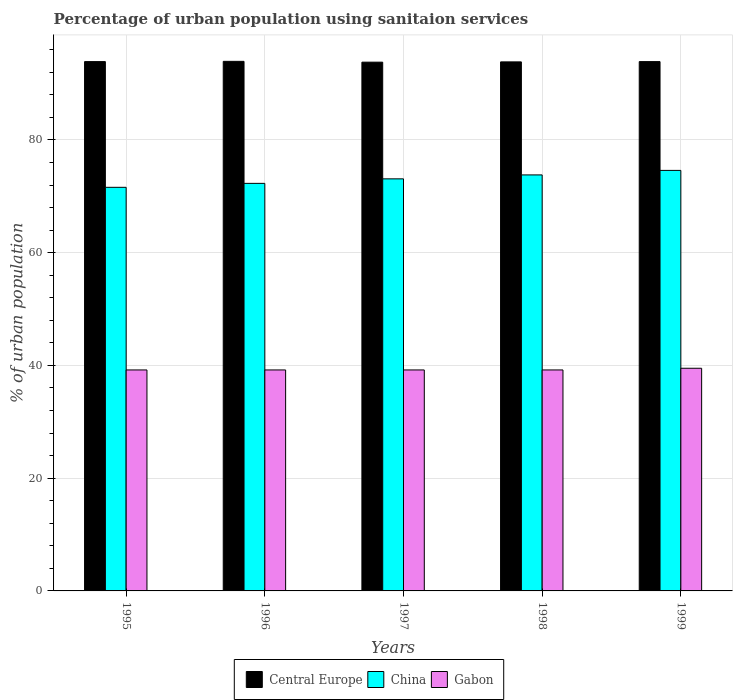How many different coloured bars are there?
Your answer should be very brief. 3. How many bars are there on the 1st tick from the left?
Your response must be concise. 3. In how many cases, is the number of bars for a given year not equal to the number of legend labels?
Ensure brevity in your answer.  0. What is the percentage of urban population using sanitaion services in Gabon in 1995?
Your response must be concise. 39.2. Across all years, what is the maximum percentage of urban population using sanitaion services in Central Europe?
Give a very brief answer. 93.95. Across all years, what is the minimum percentage of urban population using sanitaion services in Gabon?
Give a very brief answer. 39.2. In which year was the percentage of urban population using sanitaion services in China maximum?
Provide a short and direct response. 1999. What is the total percentage of urban population using sanitaion services in China in the graph?
Your response must be concise. 365.4. What is the difference between the percentage of urban population using sanitaion services in Gabon in 1995 and that in 1997?
Offer a terse response. 0. What is the difference between the percentage of urban population using sanitaion services in China in 1998 and the percentage of urban population using sanitaion services in Gabon in 1999?
Provide a short and direct response. 34.3. What is the average percentage of urban population using sanitaion services in Central Europe per year?
Provide a short and direct response. 93.88. In the year 1999, what is the difference between the percentage of urban population using sanitaion services in Gabon and percentage of urban population using sanitaion services in China?
Offer a very short reply. -35.1. What is the ratio of the percentage of urban population using sanitaion services in Gabon in 1998 to that in 1999?
Your answer should be very brief. 0.99. Is the percentage of urban population using sanitaion services in Central Europe in 1997 less than that in 1998?
Keep it short and to the point. Yes. What is the difference between the highest and the second highest percentage of urban population using sanitaion services in Central Europe?
Give a very brief answer. 0.04. What is the difference between the highest and the lowest percentage of urban population using sanitaion services in Central Europe?
Your response must be concise. 0.14. Is the sum of the percentage of urban population using sanitaion services in Central Europe in 1998 and 1999 greater than the maximum percentage of urban population using sanitaion services in Gabon across all years?
Keep it short and to the point. Yes. What does the 1st bar from the left in 1995 represents?
Your response must be concise. Central Europe. What does the 3rd bar from the right in 1995 represents?
Give a very brief answer. Central Europe. Is it the case that in every year, the sum of the percentage of urban population using sanitaion services in Gabon and percentage of urban population using sanitaion services in Central Europe is greater than the percentage of urban population using sanitaion services in China?
Offer a very short reply. Yes. Are the values on the major ticks of Y-axis written in scientific E-notation?
Give a very brief answer. No. Does the graph contain any zero values?
Keep it short and to the point. No. Does the graph contain grids?
Give a very brief answer. Yes. What is the title of the graph?
Give a very brief answer. Percentage of urban population using sanitaion services. Does "Costa Rica" appear as one of the legend labels in the graph?
Your answer should be compact. No. What is the label or title of the Y-axis?
Give a very brief answer. % of urban population. What is the % of urban population in Central Europe in 1995?
Keep it short and to the point. 93.9. What is the % of urban population of China in 1995?
Make the answer very short. 71.6. What is the % of urban population in Gabon in 1995?
Your answer should be compact. 39.2. What is the % of urban population of Central Europe in 1996?
Keep it short and to the point. 93.95. What is the % of urban population in China in 1996?
Give a very brief answer. 72.3. What is the % of urban population of Gabon in 1996?
Offer a terse response. 39.2. What is the % of urban population in Central Europe in 1997?
Give a very brief answer. 93.8. What is the % of urban population of China in 1997?
Make the answer very short. 73.1. What is the % of urban population in Gabon in 1997?
Provide a succinct answer. 39.2. What is the % of urban population of Central Europe in 1998?
Offer a terse response. 93.85. What is the % of urban population in China in 1998?
Offer a terse response. 73.8. What is the % of urban population of Gabon in 1998?
Make the answer very short. 39.2. What is the % of urban population of Central Europe in 1999?
Offer a very short reply. 93.9. What is the % of urban population in China in 1999?
Keep it short and to the point. 74.6. What is the % of urban population of Gabon in 1999?
Ensure brevity in your answer.  39.5. Across all years, what is the maximum % of urban population in Central Europe?
Provide a succinct answer. 93.95. Across all years, what is the maximum % of urban population of China?
Provide a succinct answer. 74.6. Across all years, what is the maximum % of urban population in Gabon?
Give a very brief answer. 39.5. Across all years, what is the minimum % of urban population of Central Europe?
Your answer should be compact. 93.8. Across all years, what is the minimum % of urban population in China?
Give a very brief answer. 71.6. Across all years, what is the minimum % of urban population in Gabon?
Ensure brevity in your answer.  39.2. What is the total % of urban population in Central Europe in the graph?
Your response must be concise. 469.4. What is the total % of urban population in China in the graph?
Provide a short and direct response. 365.4. What is the total % of urban population in Gabon in the graph?
Your response must be concise. 196.3. What is the difference between the % of urban population in Central Europe in 1995 and that in 1996?
Your answer should be very brief. -0.04. What is the difference between the % of urban population in Gabon in 1995 and that in 1996?
Keep it short and to the point. 0. What is the difference between the % of urban population of Central Europe in 1995 and that in 1997?
Keep it short and to the point. 0.1. What is the difference between the % of urban population in China in 1995 and that in 1997?
Your answer should be compact. -1.5. What is the difference between the % of urban population of Gabon in 1995 and that in 1997?
Your answer should be very brief. 0. What is the difference between the % of urban population of Central Europe in 1995 and that in 1998?
Your response must be concise. 0.05. What is the difference between the % of urban population of China in 1995 and that in 1998?
Make the answer very short. -2.2. What is the difference between the % of urban population of Gabon in 1995 and that in 1998?
Make the answer very short. 0. What is the difference between the % of urban population of Central Europe in 1995 and that in 1999?
Offer a very short reply. -0. What is the difference between the % of urban population in China in 1995 and that in 1999?
Your response must be concise. -3. What is the difference between the % of urban population in Central Europe in 1996 and that in 1997?
Ensure brevity in your answer.  0.14. What is the difference between the % of urban population of China in 1996 and that in 1997?
Offer a very short reply. -0.8. What is the difference between the % of urban population in Gabon in 1996 and that in 1997?
Ensure brevity in your answer.  0. What is the difference between the % of urban population in Central Europe in 1996 and that in 1998?
Make the answer very short. 0.09. What is the difference between the % of urban population of Gabon in 1996 and that in 1998?
Offer a very short reply. 0. What is the difference between the % of urban population in Central Europe in 1996 and that in 1999?
Make the answer very short. 0.04. What is the difference between the % of urban population in Central Europe in 1997 and that in 1998?
Your answer should be compact. -0.05. What is the difference between the % of urban population in China in 1997 and that in 1998?
Your answer should be very brief. -0.7. What is the difference between the % of urban population of Gabon in 1997 and that in 1998?
Provide a short and direct response. 0. What is the difference between the % of urban population in Central Europe in 1997 and that in 1999?
Keep it short and to the point. -0.1. What is the difference between the % of urban population of China in 1997 and that in 1999?
Your answer should be very brief. -1.5. What is the difference between the % of urban population in Gabon in 1997 and that in 1999?
Provide a succinct answer. -0.3. What is the difference between the % of urban population in Central Europe in 1998 and that in 1999?
Make the answer very short. -0.05. What is the difference between the % of urban population of China in 1998 and that in 1999?
Offer a terse response. -0.8. What is the difference between the % of urban population in Central Europe in 1995 and the % of urban population in China in 1996?
Offer a terse response. 21.6. What is the difference between the % of urban population of Central Europe in 1995 and the % of urban population of Gabon in 1996?
Ensure brevity in your answer.  54.7. What is the difference between the % of urban population in China in 1995 and the % of urban population in Gabon in 1996?
Offer a very short reply. 32.4. What is the difference between the % of urban population in Central Europe in 1995 and the % of urban population in China in 1997?
Keep it short and to the point. 20.8. What is the difference between the % of urban population of Central Europe in 1995 and the % of urban population of Gabon in 1997?
Offer a very short reply. 54.7. What is the difference between the % of urban population of China in 1995 and the % of urban population of Gabon in 1997?
Your response must be concise. 32.4. What is the difference between the % of urban population of Central Europe in 1995 and the % of urban population of China in 1998?
Give a very brief answer. 20.1. What is the difference between the % of urban population in Central Europe in 1995 and the % of urban population in Gabon in 1998?
Your answer should be very brief. 54.7. What is the difference between the % of urban population of China in 1995 and the % of urban population of Gabon in 1998?
Your answer should be very brief. 32.4. What is the difference between the % of urban population of Central Europe in 1995 and the % of urban population of China in 1999?
Provide a succinct answer. 19.3. What is the difference between the % of urban population in Central Europe in 1995 and the % of urban population in Gabon in 1999?
Your response must be concise. 54.4. What is the difference between the % of urban population of China in 1995 and the % of urban population of Gabon in 1999?
Your answer should be very brief. 32.1. What is the difference between the % of urban population of Central Europe in 1996 and the % of urban population of China in 1997?
Keep it short and to the point. 20.85. What is the difference between the % of urban population of Central Europe in 1996 and the % of urban population of Gabon in 1997?
Give a very brief answer. 54.75. What is the difference between the % of urban population in China in 1996 and the % of urban population in Gabon in 1997?
Offer a terse response. 33.1. What is the difference between the % of urban population of Central Europe in 1996 and the % of urban population of China in 1998?
Your response must be concise. 20.15. What is the difference between the % of urban population in Central Europe in 1996 and the % of urban population in Gabon in 1998?
Make the answer very short. 54.75. What is the difference between the % of urban population in China in 1996 and the % of urban population in Gabon in 1998?
Keep it short and to the point. 33.1. What is the difference between the % of urban population in Central Europe in 1996 and the % of urban population in China in 1999?
Provide a short and direct response. 19.35. What is the difference between the % of urban population in Central Europe in 1996 and the % of urban population in Gabon in 1999?
Provide a succinct answer. 54.45. What is the difference between the % of urban population in China in 1996 and the % of urban population in Gabon in 1999?
Provide a short and direct response. 32.8. What is the difference between the % of urban population in Central Europe in 1997 and the % of urban population in China in 1998?
Your response must be concise. 20. What is the difference between the % of urban population in Central Europe in 1997 and the % of urban population in Gabon in 1998?
Your answer should be very brief. 54.6. What is the difference between the % of urban population in China in 1997 and the % of urban population in Gabon in 1998?
Provide a succinct answer. 33.9. What is the difference between the % of urban population in Central Europe in 1997 and the % of urban population in China in 1999?
Keep it short and to the point. 19.2. What is the difference between the % of urban population of Central Europe in 1997 and the % of urban population of Gabon in 1999?
Offer a terse response. 54.3. What is the difference between the % of urban population of China in 1997 and the % of urban population of Gabon in 1999?
Your answer should be very brief. 33.6. What is the difference between the % of urban population of Central Europe in 1998 and the % of urban population of China in 1999?
Your response must be concise. 19.25. What is the difference between the % of urban population of Central Europe in 1998 and the % of urban population of Gabon in 1999?
Provide a short and direct response. 54.35. What is the difference between the % of urban population of China in 1998 and the % of urban population of Gabon in 1999?
Your answer should be very brief. 34.3. What is the average % of urban population of Central Europe per year?
Offer a very short reply. 93.88. What is the average % of urban population of China per year?
Your answer should be very brief. 73.08. What is the average % of urban population in Gabon per year?
Your answer should be very brief. 39.26. In the year 1995, what is the difference between the % of urban population in Central Europe and % of urban population in China?
Your answer should be compact. 22.3. In the year 1995, what is the difference between the % of urban population of Central Europe and % of urban population of Gabon?
Make the answer very short. 54.7. In the year 1995, what is the difference between the % of urban population of China and % of urban population of Gabon?
Your response must be concise. 32.4. In the year 1996, what is the difference between the % of urban population of Central Europe and % of urban population of China?
Offer a terse response. 21.65. In the year 1996, what is the difference between the % of urban population in Central Europe and % of urban population in Gabon?
Keep it short and to the point. 54.75. In the year 1996, what is the difference between the % of urban population of China and % of urban population of Gabon?
Make the answer very short. 33.1. In the year 1997, what is the difference between the % of urban population of Central Europe and % of urban population of China?
Offer a very short reply. 20.7. In the year 1997, what is the difference between the % of urban population of Central Europe and % of urban population of Gabon?
Provide a short and direct response. 54.6. In the year 1997, what is the difference between the % of urban population in China and % of urban population in Gabon?
Make the answer very short. 33.9. In the year 1998, what is the difference between the % of urban population in Central Europe and % of urban population in China?
Provide a succinct answer. 20.05. In the year 1998, what is the difference between the % of urban population of Central Europe and % of urban population of Gabon?
Your answer should be very brief. 54.65. In the year 1998, what is the difference between the % of urban population in China and % of urban population in Gabon?
Provide a succinct answer. 34.6. In the year 1999, what is the difference between the % of urban population in Central Europe and % of urban population in China?
Keep it short and to the point. 19.3. In the year 1999, what is the difference between the % of urban population in Central Europe and % of urban population in Gabon?
Your response must be concise. 54.4. In the year 1999, what is the difference between the % of urban population in China and % of urban population in Gabon?
Your answer should be very brief. 35.1. What is the ratio of the % of urban population of China in 1995 to that in 1996?
Keep it short and to the point. 0.99. What is the ratio of the % of urban population of Central Europe in 1995 to that in 1997?
Give a very brief answer. 1. What is the ratio of the % of urban population in China in 1995 to that in 1997?
Give a very brief answer. 0.98. What is the ratio of the % of urban population in Central Europe in 1995 to that in 1998?
Your answer should be very brief. 1. What is the ratio of the % of urban population in China in 1995 to that in 1998?
Keep it short and to the point. 0.97. What is the ratio of the % of urban population of Gabon in 1995 to that in 1998?
Make the answer very short. 1. What is the ratio of the % of urban population in Central Europe in 1995 to that in 1999?
Offer a very short reply. 1. What is the ratio of the % of urban population in China in 1995 to that in 1999?
Your answer should be very brief. 0.96. What is the ratio of the % of urban population in China in 1996 to that in 1997?
Ensure brevity in your answer.  0.99. What is the ratio of the % of urban population of Gabon in 1996 to that in 1997?
Provide a short and direct response. 1. What is the ratio of the % of urban population in China in 1996 to that in 1998?
Provide a short and direct response. 0.98. What is the ratio of the % of urban population of Gabon in 1996 to that in 1998?
Keep it short and to the point. 1. What is the ratio of the % of urban population of China in 1996 to that in 1999?
Your answer should be very brief. 0.97. What is the ratio of the % of urban population in China in 1997 to that in 1998?
Give a very brief answer. 0.99. What is the ratio of the % of urban population of Gabon in 1997 to that in 1998?
Offer a terse response. 1. What is the ratio of the % of urban population of China in 1997 to that in 1999?
Ensure brevity in your answer.  0.98. What is the ratio of the % of urban population in Gabon in 1997 to that in 1999?
Keep it short and to the point. 0.99. What is the ratio of the % of urban population in China in 1998 to that in 1999?
Offer a very short reply. 0.99. What is the difference between the highest and the second highest % of urban population in Central Europe?
Your answer should be compact. 0.04. What is the difference between the highest and the second highest % of urban population in China?
Make the answer very short. 0.8. What is the difference between the highest and the second highest % of urban population of Gabon?
Make the answer very short. 0.3. What is the difference between the highest and the lowest % of urban population in Central Europe?
Give a very brief answer. 0.14. 